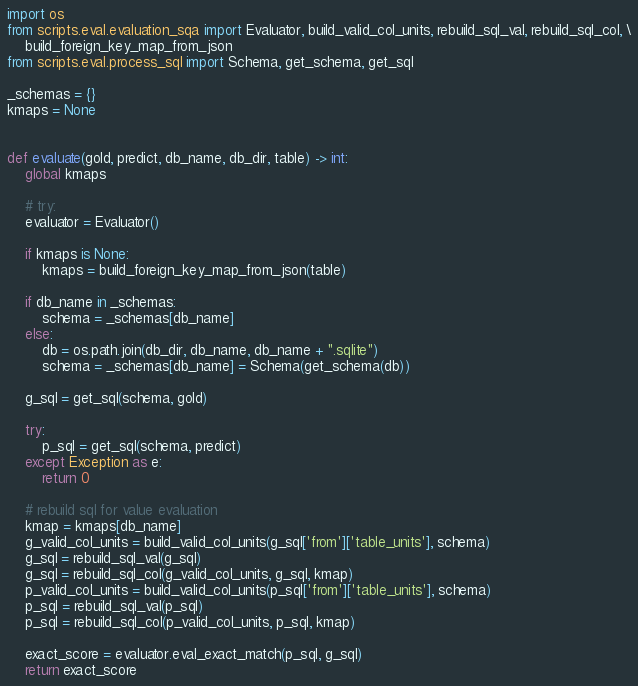Convert code to text. <code><loc_0><loc_0><loc_500><loc_500><_Python_>
import os
from scripts.eval.evaluation_sqa import Evaluator, build_valid_col_units, rebuild_sql_val, rebuild_sql_col, \
    build_foreign_key_map_from_json
from scripts.eval.process_sql import Schema, get_schema, get_sql

_schemas = {}
kmaps = None


def evaluate(gold, predict, db_name, db_dir, table) -> int:
    global kmaps

    # try:
    evaluator = Evaluator()

    if kmaps is None:
        kmaps = build_foreign_key_map_from_json(table)

    if db_name in _schemas:
        schema = _schemas[db_name]
    else:
        db = os.path.join(db_dir, db_name, db_name + ".sqlite")
        schema = _schemas[db_name] = Schema(get_schema(db))

    g_sql = get_sql(schema, gold)

    try:
        p_sql = get_sql(schema, predict)
    except Exception as e:
        return 0

    # rebuild sql for value evaluation
    kmap = kmaps[db_name]
    g_valid_col_units = build_valid_col_units(g_sql['from']['table_units'], schema)
    g_sql = rebuild_sql_val(g_sql)
    g_sql = rebuild_sql_col(g_valid_col_units, g_sql, kmap)
    p_valid_col_units = build_valid_col_units(p_sql['from']['table_units'], schema)
    p_sql = rebuild_sql_val(p_sql)
    p_sql = rebuild_sql_col(p_valid_col_units, p_sql, kmap)

    exact_score = evaluator.eval_exact_match(p_sql, g_sql)
    return exact_score

</code> 